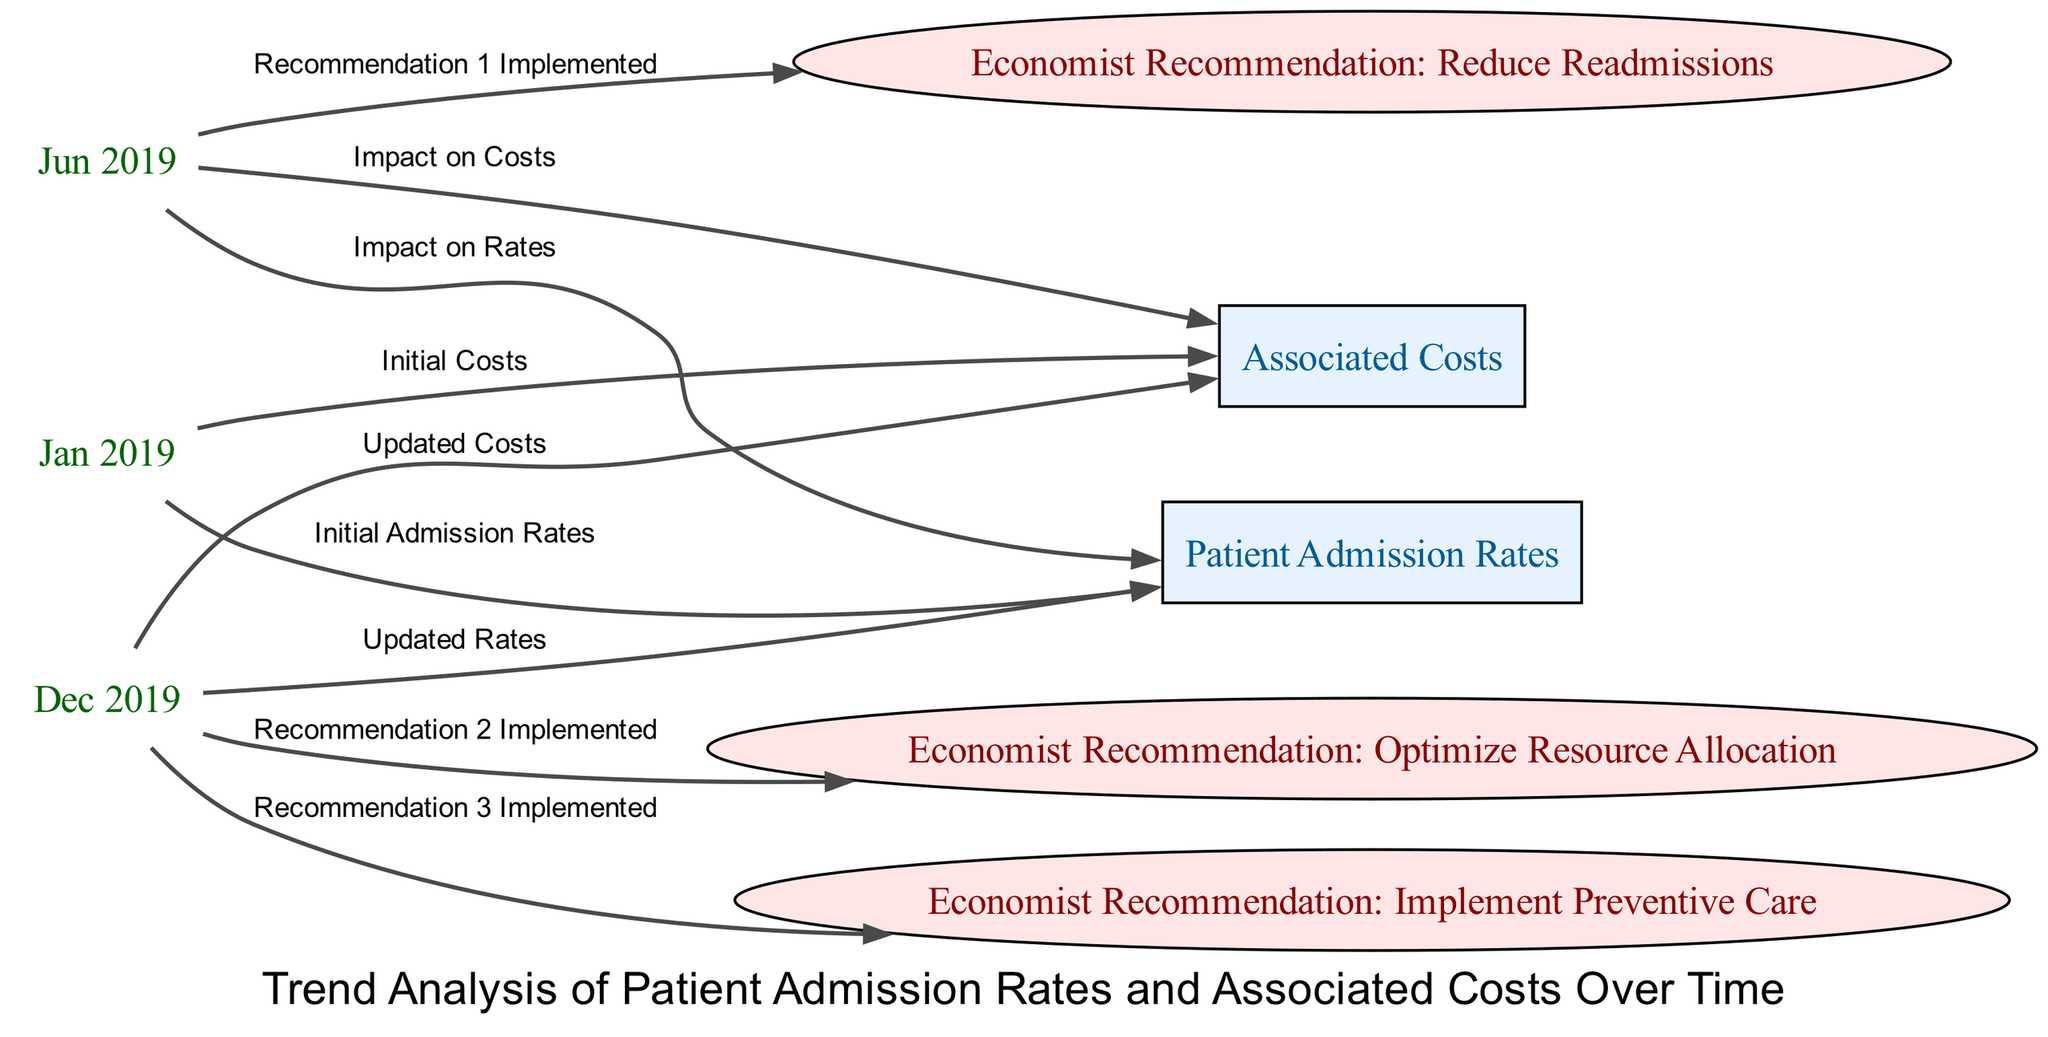What is the initial date represented in the diagram? The earliest date shown in the diagram is "Jan 2019," which is connected to the nodes for patient admission rates and associated costs.
Answer: Jan 2019 What type of intervention is highlighted at "Jun 2019"? The node connected at "Jun 2019" shows the intervention labeled "Economist Recommendation: Reduce Readmissions," indicating it is a recommendation related to patient care.
Answer: Reduce Readmissions How many intervention points are indicated in the diagram? There are three intervention points connected to specific date nodes, each representing different recommendations made by the economist.
Answer: 3 What happened to patient admission rates between "Jan 2019" and "Dec 2019"? The diagram shows that patient admission rates were updated by the end of the timeline, indicating a potential decrease or adjustment as a result of implemented interventions.
Answer: Updated Rates What relationship exists between "Dec 2019" and the costs associated with patient admissions? The diagram illustrates that on "Dec 2019," there is a direct link to the updated costs, implying that changes or interventions may have affected the financial aspects of patient admissions.
Answer: Updated Costs What is the impact of the economist's recommendations on associated costs by "Jun 2019"? The edges in the diagram indicate that, at "Jun 2019," there is a direct impact shown on associated costs as a result of the implemented recommendation to reduce readmissions.
Answer: Impact on Costs Which specific intervention was implemented last in the diagram? The last intervention indicated is "Economist Recommendation: Implement Preventive Care," shown connected to "Dec 2019" in the diagram.
Answer: Implement Preventive Care Are there more nodes representing trends or interventions in the diagram? Upon counting, the diagram displays more trend nodes (patient admission rates and associated costs) than intervention nodes, as the trends are crucial for understanding the overall data flow.
Answer: Trends What does the label "Initial Admission Rates" refer to in relation to "Jan 2019"? The label indicates that it marks the starting point for measuring patient admission rates and is directly associated with the node for patient admission rates at that date.
Answer: Initial Admission Rates 